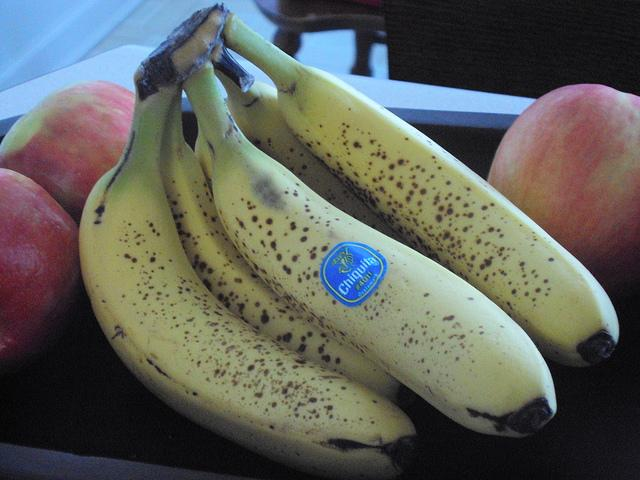Which fruit is too ripe? Please explain your reasoning. banana. The yellow curved fruit is beginning to get black spots on it as it starts to overripen. 